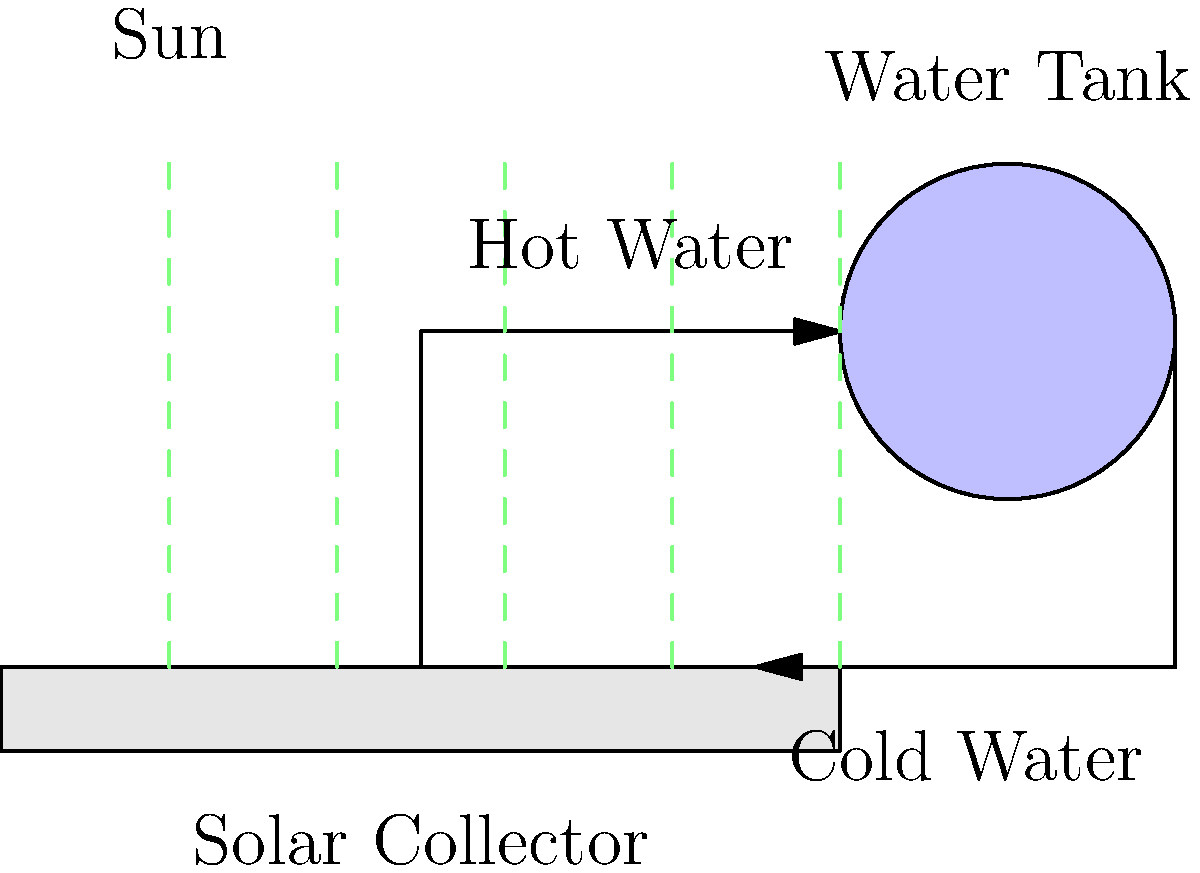In a simple DIY solar water heater system, water circulates between a solar collector and an insulated storage tank. The collector absorbs solar energy, heating the water, which then rises to the tank due to natural convection. If the solar collector has an area of 2 m² and receives an average solar irradiance of 800 W/m², what is the maximum theoretical amount of heat energy (in kJ) that can be transferred to the water in 1 hour, assuming 100% efficiency? To solve this problem, we need to follow these steps:

1. Understand the given information:
   - Solar collector area (A) = 2 m²
   - Solar irradiance (I) = 800 W/m²
   - Time (t) = 1 hour = 3600 seconds
   - Efficiency = 100% (theoretical maximum)

2. Calculate the power received by the solar collector:
   Power (P) = Irradiance × Area
   $P = I \times A = 800 \text{ W/m²} \times 2 \text{ m²} = 1600 \text{ W}$

3. Calculate the energy transferred over time:
   Energy (E) = Power × Time
   $E = P \times t = 1600 \text{ W} \times 3600 \text{ s} = 5,760,000 \text{ J}$

4. Convert joules to kilojoules:
   $5,760,000 \text{ J} = 5,760 \text{ kJ}$

Therefore, the maximum theoretical amount of heat energy that can be transferred to the water in 1 hour is 5,760 kJ.
Answer: 5,760 kJ 